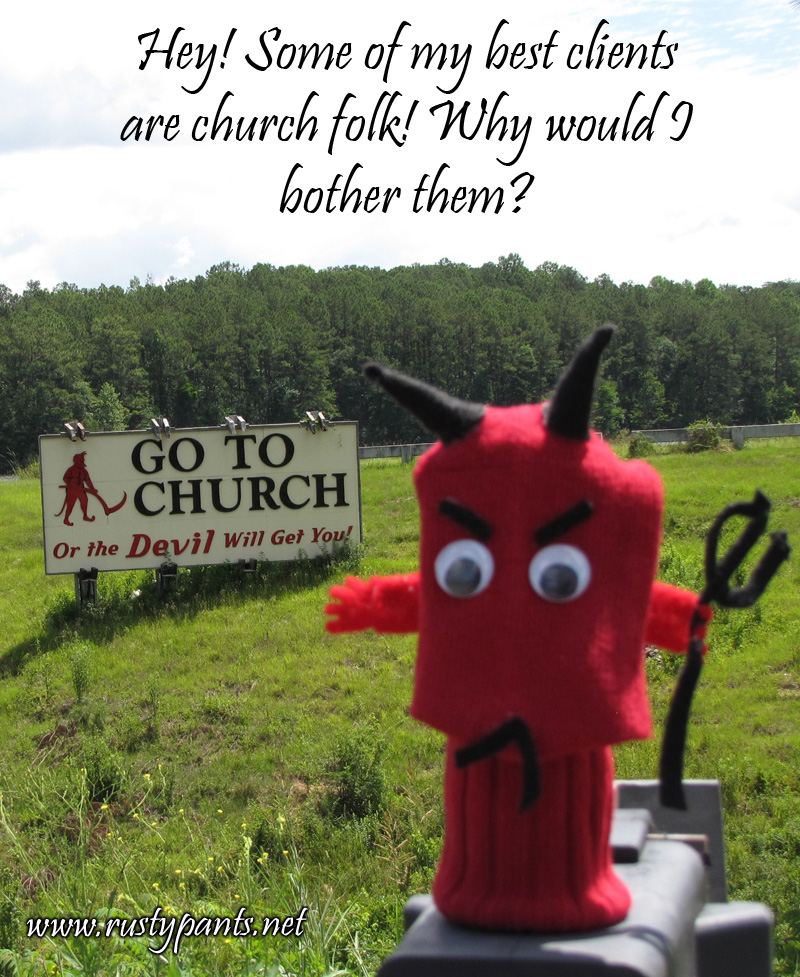What does the character's expression convey about the context or humor involved in this scene? The character, resembling a devil with a playful and slightly mischievous expression, adds a layer of irony and humor to the scene. Its presence in front of the church-related sign, pretending to be shocked or protesting, suggests satire. The humorous juxtaposition serves to engage viewers and elicit a reaction, perhaps a smile or a deeper reflection on religious themes contrasted with modern interpretations of good and evil.  Could there be a deeper meaning to using such imagery in this public setting? Certainly, the use of such striking and somewhat controversial imagery in a public setting might be intended to spark conversation and reflection about religious attendance and moral behavior in society. It questions conventional motifs through humor and satire, potentially pushing viewers to think about the role of religion in their lives and in modern society. The imagery could also be seen as a commentary on fear-based motivations for religious engagement, inviting contemplation on the reasons people choose to attend church. 